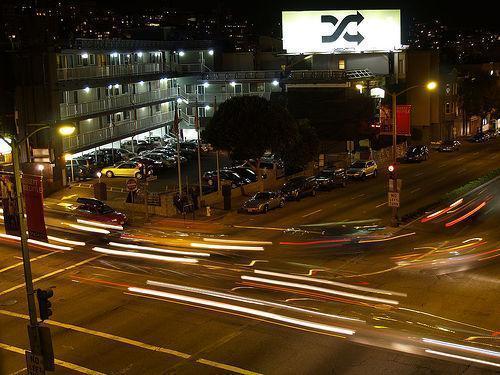How many lights are on the light poll?
Give a very brief answer. 2. How many cars are parked along the curb?
Give a very brief answer. 7. How many floors are there?
Give a very brief answer. 3. How many floors is the building?
Give a very brief answer. 3. 